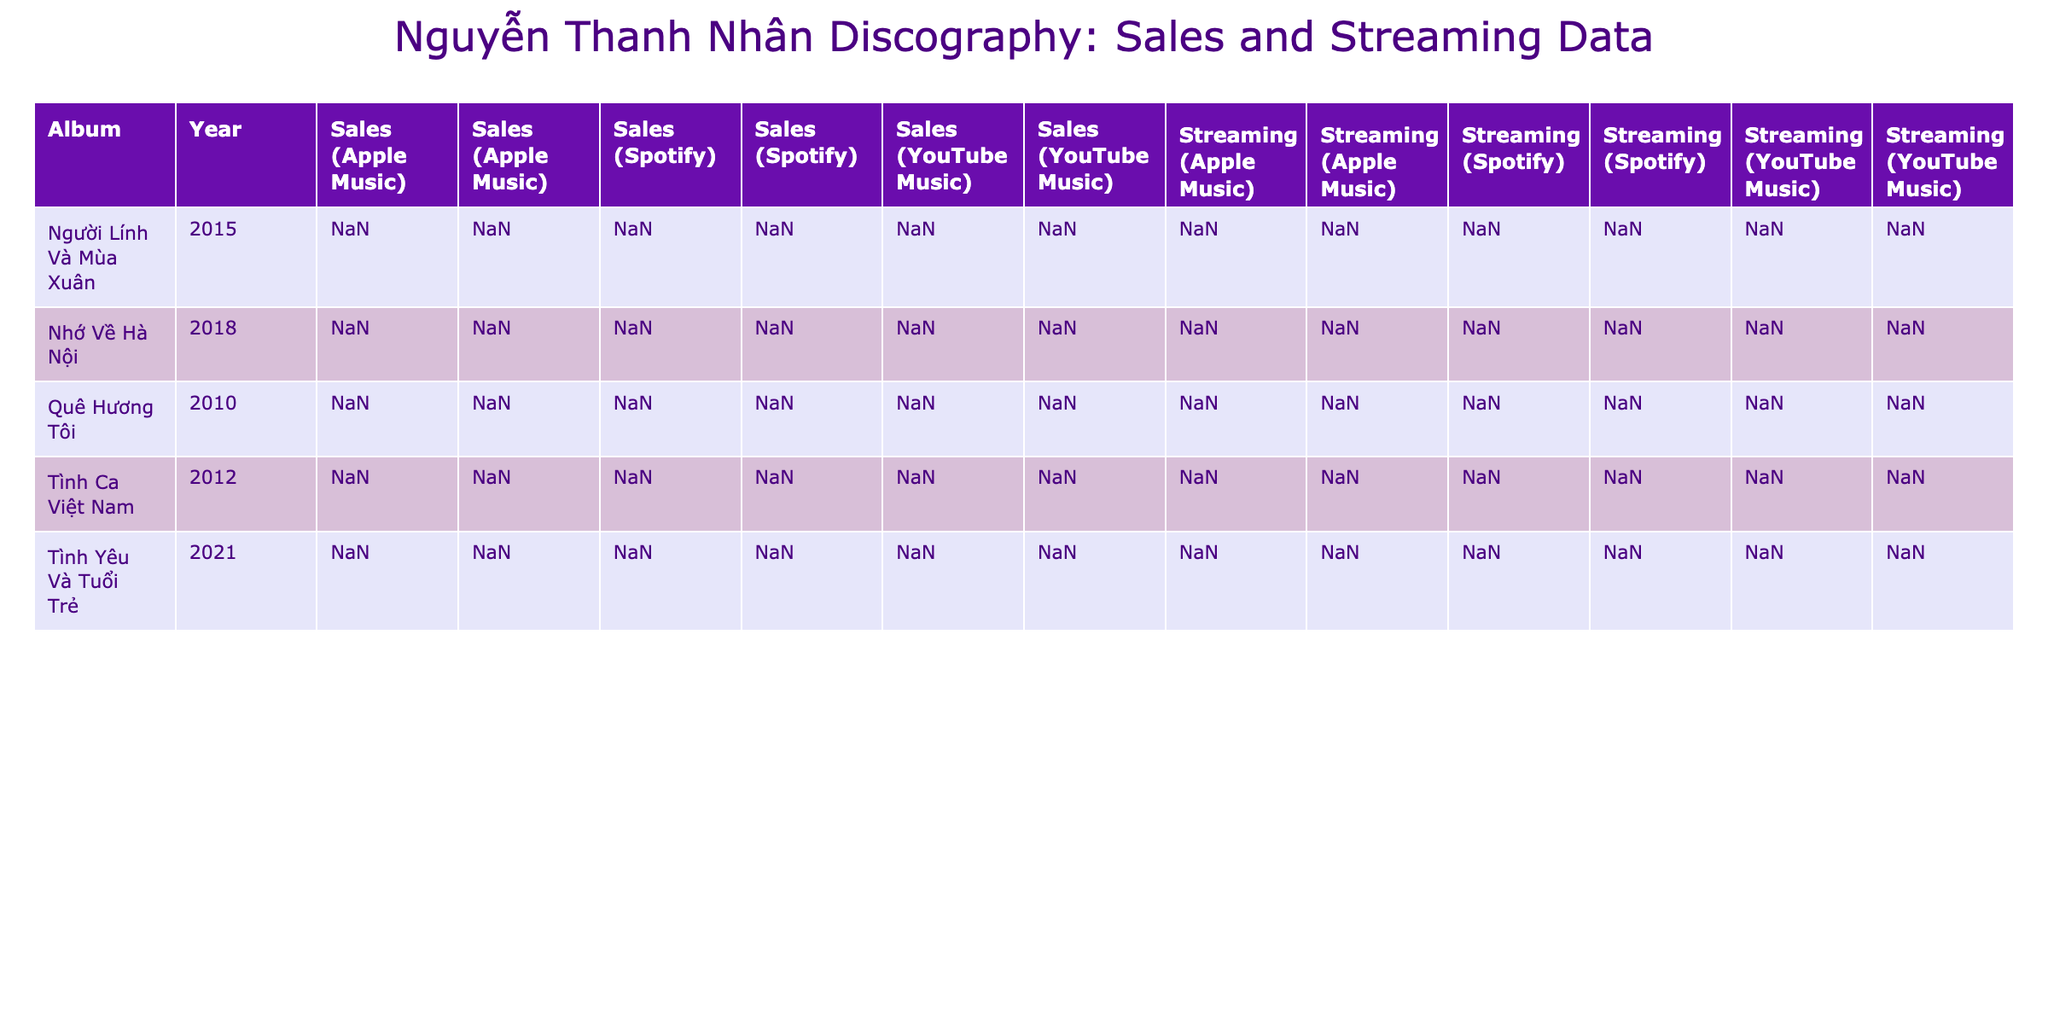What were the total sales of the album "Nhớ Về Hà Nội"? The table shows individual sales figures for each platform and region for "Nhớ Về Hà Nội." The sales are 120000, 80000, 60000, 40000, and 20000 for different platforms and regions. Adding these values together gives: 120000 + 80000 + 60000 + 40000 + 20000 = 400000.
Answer: 400000 Which album had the highest number of sales in 2021? Looking at the sales numbers in 2021, "Tình Yêu Và Tuổi Trẻ" has sales figures of 150000, 100000, and 80000 across different platforms in Vietnam and 60000, 30000, and 20000 internationally. The highest total is 150000.
Answer: Tình Yêu Và Tuổi Trẻ Is the streaming number for "Người Lính Và Mùa Xuân" outside of Vietnam higher than the streaming number for "Tình Ca Việt Nam" on all platforms? For "Người Lính Và Mùa Xuân," the streaming numbers outside of Vietnam are 1500000 (Spotify) and 500000 (Apple Music), totaling 2000000. For "Tình Ca Việt Nam," outside Vietnam, the streaming is 750000 (Spotify) totaling 750000. Since 2000000 is greater than 750000, the answer is yes.
Answer: Yes What is the average streaming number for "Quê Hương Tôi"? The streaming numbers for "Quê Hương Tôi" are 2000000, 1500000, and 500000 across different platforms and regions. First, we sum these values: 2000000 + 1500000 + 500000 = 4000000. There are 3 data points, so the average is 4000000 divided by 3, which equals 133333.33.
Answer: 133333.33 Was there an album released in 2015 that had lower total streaming numbers compared to any album released in 2018? Looking at the streaming numbers, for "Người Lính Và Mùa Xuân" (2015), the totals are: 5000000, 3000000, 2000000, 1500000, and 500000, summing to 10000000. For 2018 "Nhớ Về Hà Nội," the totals are: 8000000, 5000000, 3500000, 2500000, and 1000000, summing to 20000000. Comparing these totals, 10000000 is lower than 20000000, hence the answer is yes.
Answer: Yes 